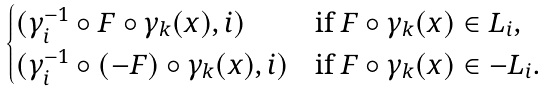Convert formula to latex. <formula><loc_0><loc_0><loc_500><loc_500>\begin{cases} ( \gamma ^ { - 1 } _ { i } \circ F \circ \gamma _ { k } ( x ) , i ) & \text {if $F\circ \gamma_{k} (x) \in L_{i}$,} \\ ( \gamma ^ { - 1 } _ { i } \circ ( - F ) \circ \gamma _ { k } ( x ) , i ) & \text {if $F\circ \gamma_{k} (x) \in -L_{i}$.} \\ \end{cases}</formula> 